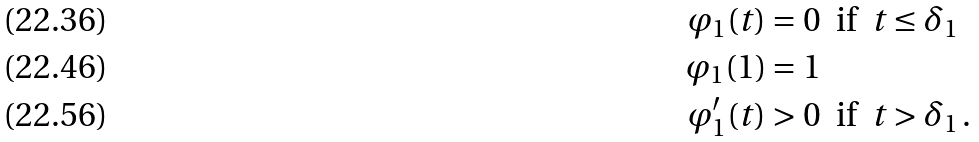Convert formula to latex. <formula><loc_0><loc_0><loc_500><loc_500>\varphi _ { 1 } ( t ) & = 0 \ \text { if } \ t \leq \delta _ { 1 } \\ \varphi _ { 1 } ( 1 ) & = 1 \\ \varphi _ { 1 } ^ { \prime } ( t ) & > 0 \ \text { if } \ t > \delta _ { 1 } \, .</formula> 